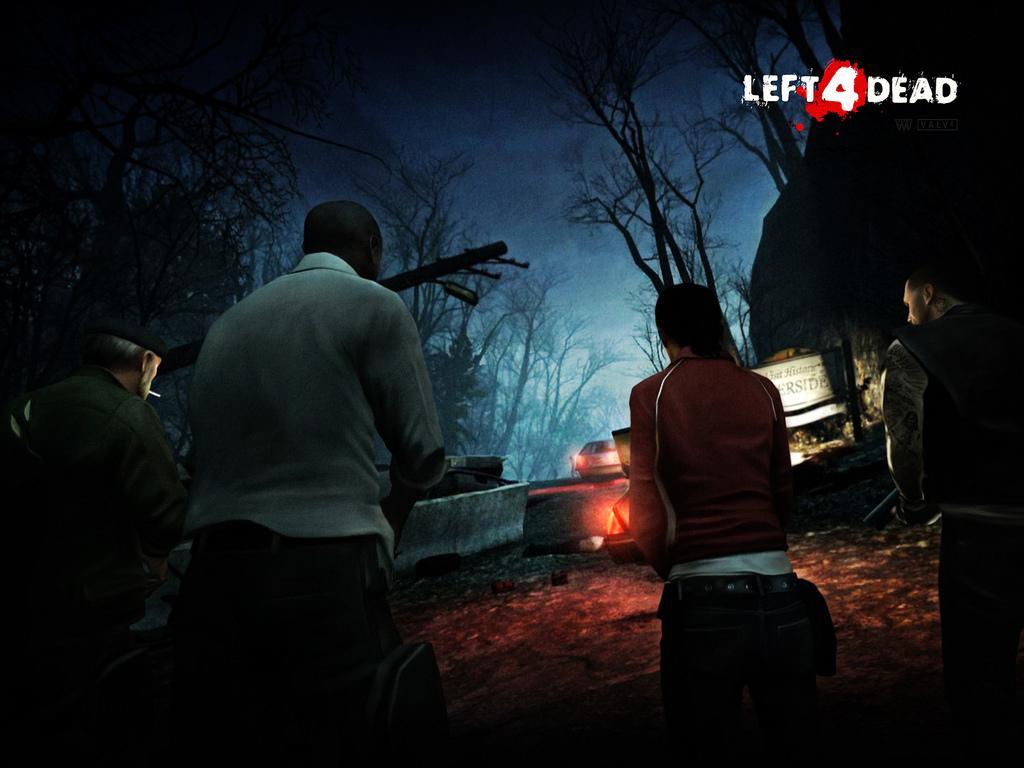Can you describe this image briefly? This is an animated picture where we can see these people are standing here, we can see a vehicle on the road, we can see the wall, trees and the dark sky in the background. 